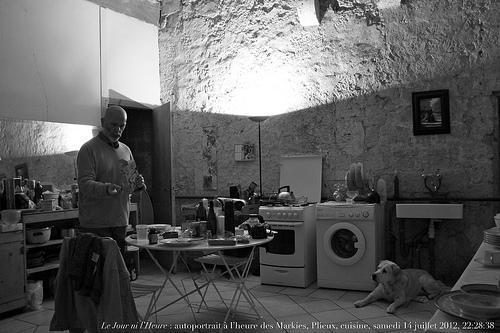How many dogs?
Give a very brief answer. 1. How many major appliances are in the room?
Give a very brief answer. 2. 